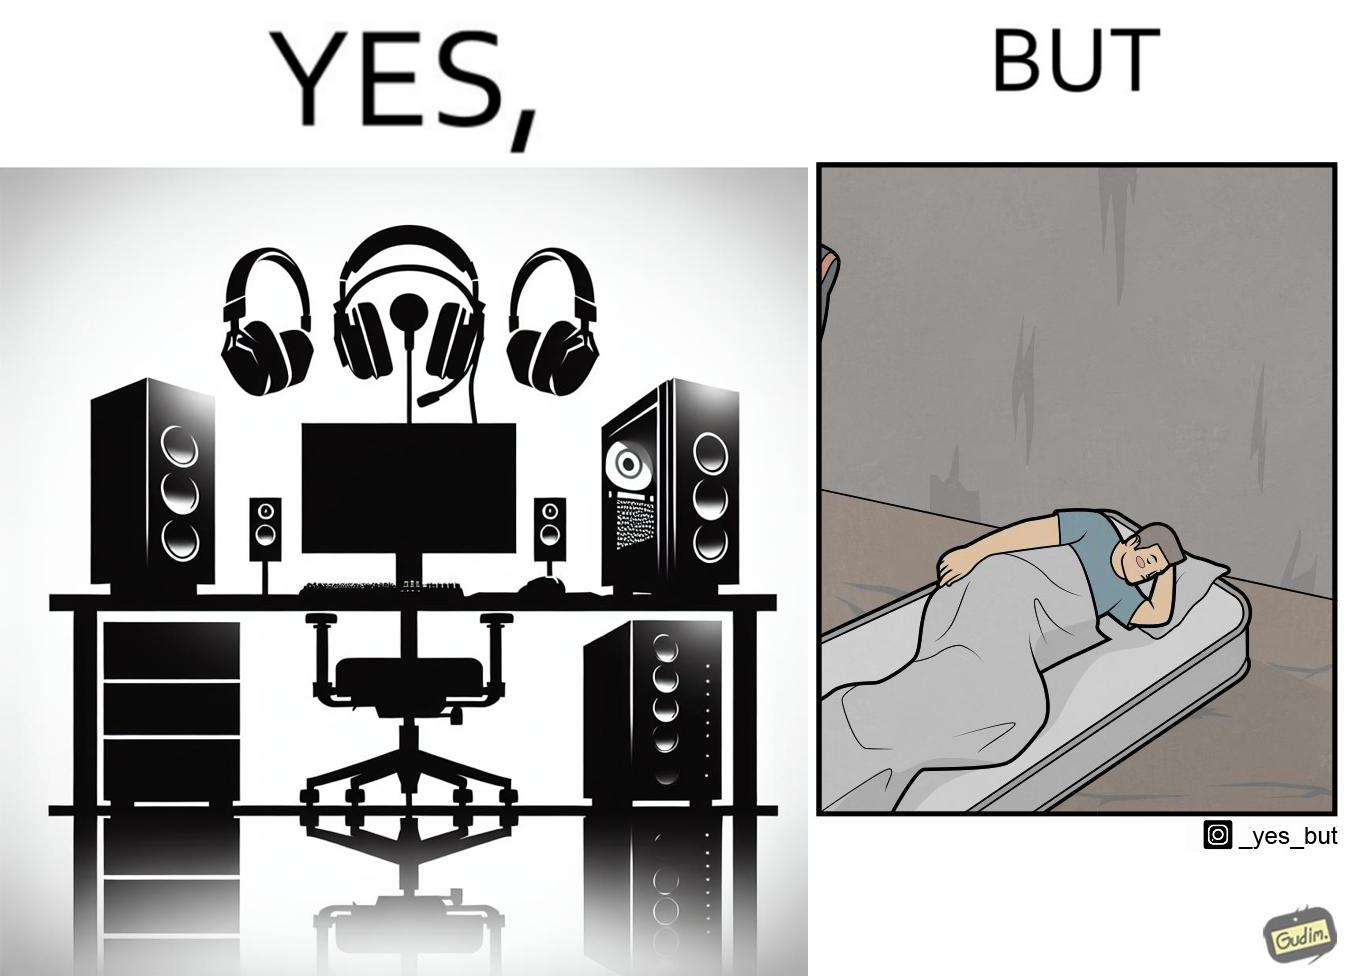Explain the humor or irony in this image. The image is funny because the person has a lot of furniture for his computer but none for himself. 